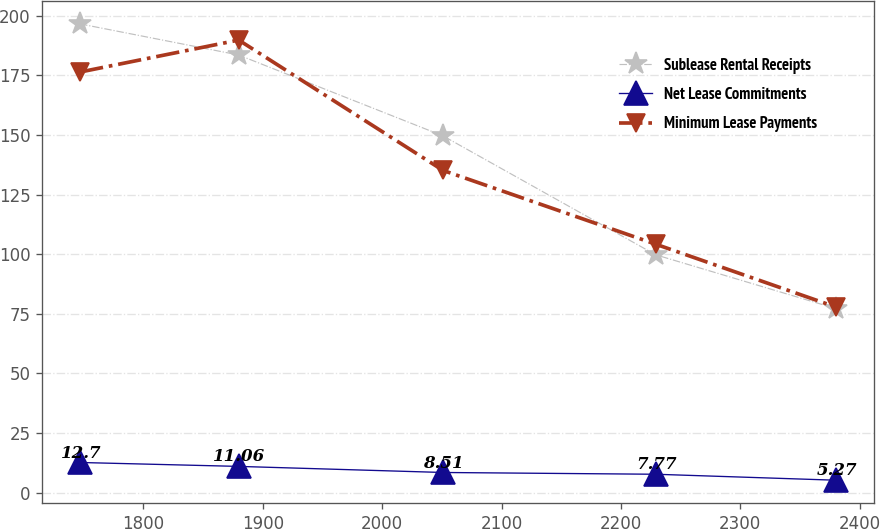Convert chart to OTSL. <chart><loc_0><loc_0><loc_500><loc_500><line_chart><ecel><fcel>Sublease Rental Receipts<fcel>Net Lease Commitments<fcel>Minimum Lease Payments<nl><fcel>1746.86<fcel>196.52<fcel>12.7<fcel>176.34<nl><fcel>1879.78<fcel>183.48<fcel>11.06<fcel>189.75<nl><fcel>2051.03<fcel>149.57<fcel>8.51<fcel>135.1<nl><fcel>2229.04<fcel>99.76<fcel>7.77<fcel>104.21<nl><fcel>2380.23<fcel>77.19<fcel>5.27<fcel>77.85<nl></chart> 